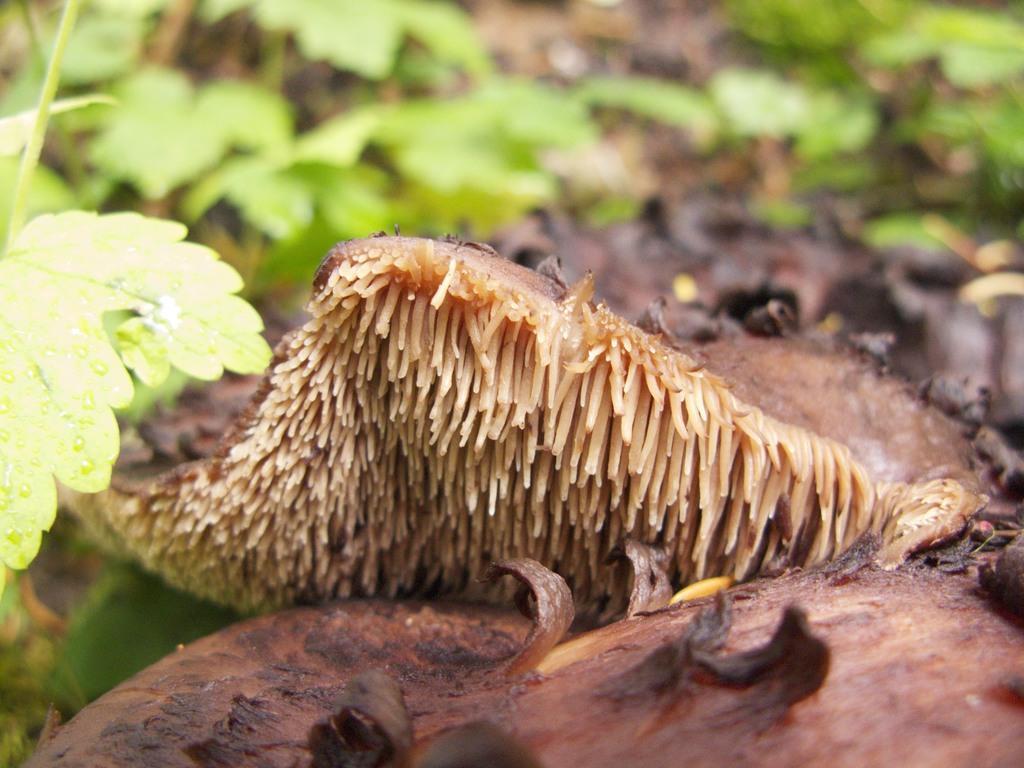Describe this image in one or two sentences. In this image, we can see some brown color objects. Background we can see few plants with leaves. 